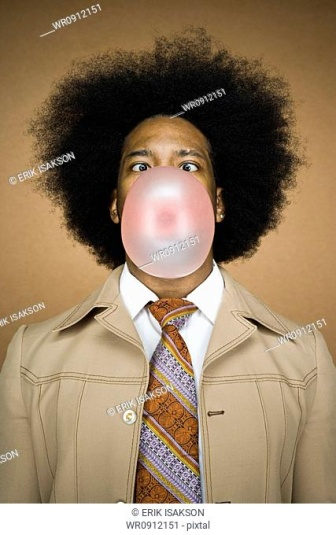Describe the mood and emotion conveyed by the person in the image. The image conveys a playful and whimsical mood through the act of blowing a bubble with bubble gum, a light-hearted activity often associated with fun and leisure. The person's wide-eyed expression enhances the humorous and slightly surprised look, adding to the overall cheerful and spirited feeling of the photograph. The vibrant colors of their tie against the neutral jacket and the solid orange background further contribute to a lively and dynamic atmosphere. 